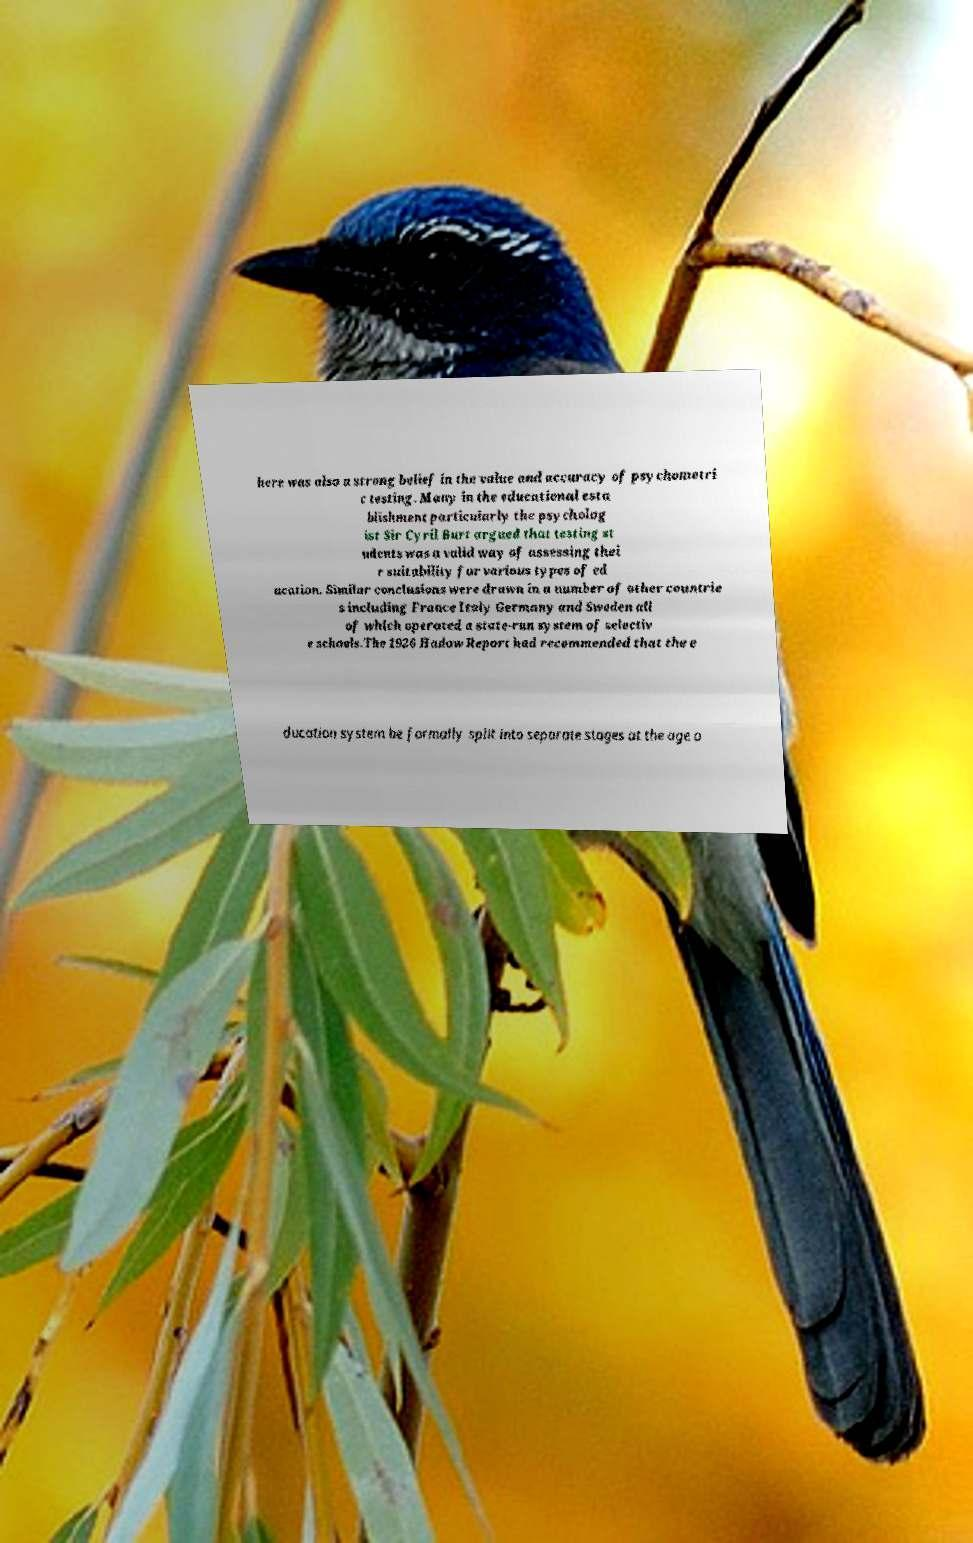There's text embedded in this image that I need extracted. Can you transcribe it verbatim? here was also a strong belief in the value and accuracy of psychometri c testing. Many in the educational esta blishment particularly the psycholog ist Sir Cyril Burt argued that testing st udents was a valid way of assessing thei r suitability for various types of ed ucation. Similar conclusions were drawn in a number of other countrie s including France Italy Germany and Sweden all of which operated a state-run system of selectiv e schools.The 1926 Hadow Report had recommended that the e ducation system be formally split into separate stages at the age o 